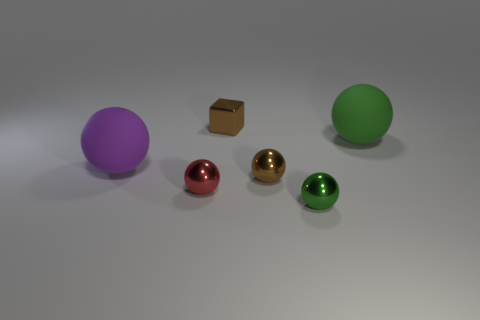Is there anything else that has the same shape as the red shiny thing?
Make the answer very short. Yes. Do the small red object and the large green object have the same material?
Offer a very short reply. No. There is a tiny metallic sphere that is on the left side of the metallic block; are there any small metallic balls that are in front of it?
Your response must be concise. Yes. How many things are both behind the brown metallic sphere and to the left of the small green thing?
Your answer should be very brief. 2. The large matte thing right of the red object has what shape?
Keep it short and to the point. Sphere. What number of red balls have the same size as the metallic cube?
Your answer should be compact. 1. Do the rubber sphere that is to the right of the brown shiny cube and the tiny shiny cube have the same color?
Ensure brevity in your answer.  No. There is a object that is both right of the brown ball and behind the red metal object; what is its material?
Ensure brevity in your answer.  Rubber. Is the number of red things greater than the number of cyan objects?
Provide a succinct answer. Yes. The tiny metal thing behind the large rubber ball that is to the right of the metallic thing to the right of the brown ball is what color?
Your answer should be very brief. Brown. 